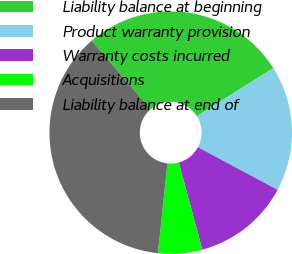Convert chart. <chart><loc_0><loc_0><loc_500><loc_500><pie_chart><fcel>Liability balance at beginning<fcel>Product warranty provision<fcel>Warranty costs incurred<fcel>Acquisitions<fcel>Liability balance at end of<nl><fcel>27.37%<fcel>16.75%<fcel>12.98%<fcel>5.88%<fcel>37.02%<nl></chart> 